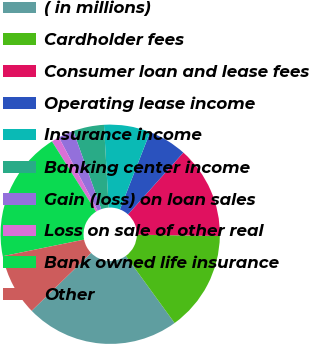Convert chart to OTSL. <chart><loc_0><loc_0><loc_500><loc_500><pie_chart><fcel>( in millions)<fcel>Cardholder fees<fcel>Consumer loan and lease fees<fcel>Operating lease income<fcel>Insurance income<fcel>Banking center income<fcel>Gain (loss) on loan sales<fcel>Loss on sale of other real<fcel>Bank owned life insurance<fcel>Other<nl><fcel>22.69%<fcel>14.76%<fcel>13.63%<fcel>5.69%<fcel>6.83%<fcel>4.56%<fcel>2.29%<fcel>1.16%<fcel>19.29%<fcel>9.09%<nl></chart> 